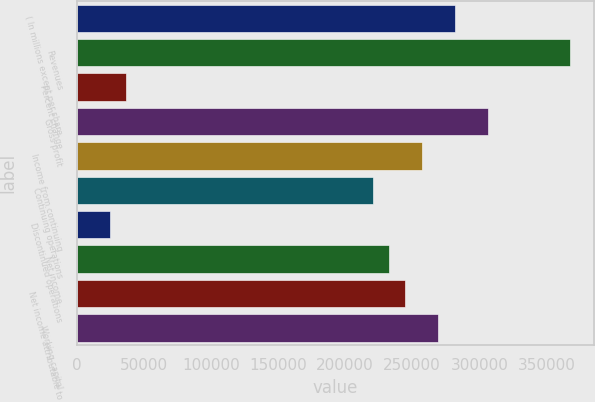Convert chart to OTSL. <chart><loc_0><loc_0><loc_500><loc_500><bar_chart><fcel>( In millions except per share<fcel>Revenues<fcel>Percent change<fcel>Gross profit<fcel>Income from continuing<fcel>Continuing operations<fcel>Discontinued operations<fcel>Net income<fcel>Net income attributable to<fcel>Working capital<nl><fcel>281641<fcel>367357<fcel>36736.5<fcel>306131<fcel>257150<fcel>220415<fcel>24491.2<fcel>232660<fcel>244905<fcel>269396<nl></chart> 